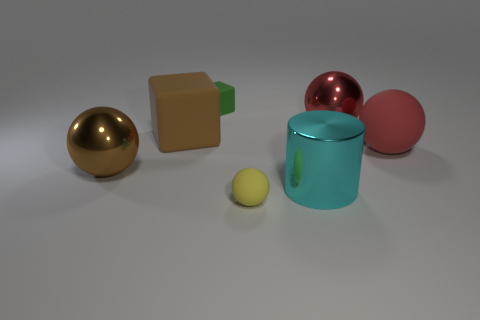Can you tell me what objects are present in this image? Certainly! The image features a collection of objects comprising a large gold-colored metallic ball, a small yellow matte ball, a green rectangular prism possibly made of plastic, a shiny red sphere, and a cylindrical teal mug with a handle. Do any of these objects appear to have a particular function or are they just for decoration? The objects in the image seem to be staged for illustrative or artistic purposes rather than functionality. The cylindrical teal mug is the only item that traditionally serves a functional purpose, being a container for liquids. 